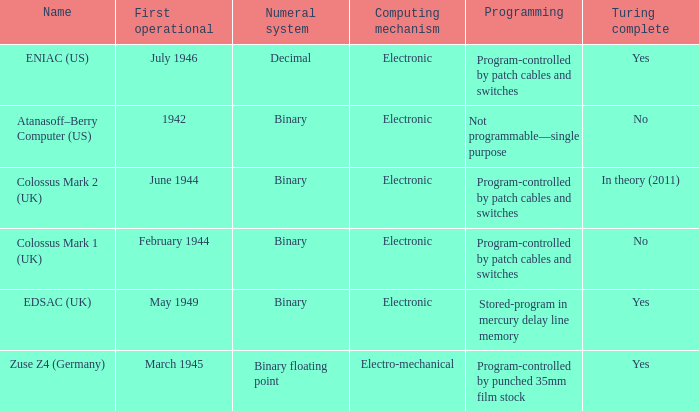What's the computing mechanbeingm with name being atanasoff–berry computer (us) Electronic. 